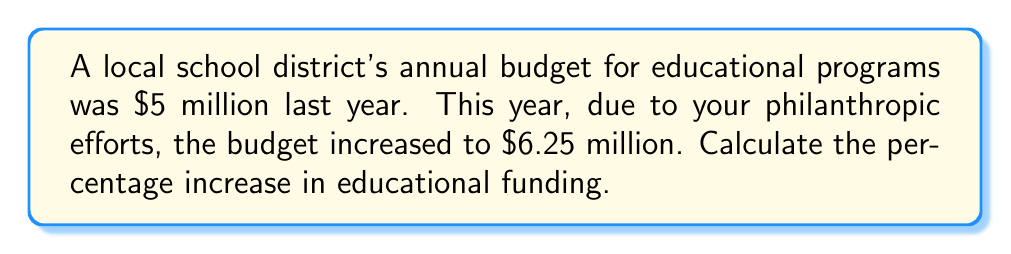Can you solve this math problem? To calculate the percentage increase, we need to follow these steps:

1. Calculate the difference between the new and original amounts:
   $6.25 \text{ million} - $5 \text{ million} = $1.25 \text{ million}

2. Divide the increase by the original amount:
   $$\frac{\text{Increase}}{\text{Original Amount}} = \frac{1.25}{5} = 0.25$$

3. Convert the decimal to a percentage by multiplying by 100:
   $$0.25 \times 100 = 25\%$$

Therefore, the percentage increase in educational funding is 25%.

Alternatively, we can use the formula:

$$\text{Percentage Increase} = \frac{\text{New Amount} - \text{Original Amount}}{\text{Original Amount}} \times 100\%$$

$$= \frac{6.25 - 5}{5} \times 100\% = \frac{1.25}{5} \times 100\% = 0.25 \times 100\% = 25\%$$
Answer: 25% 